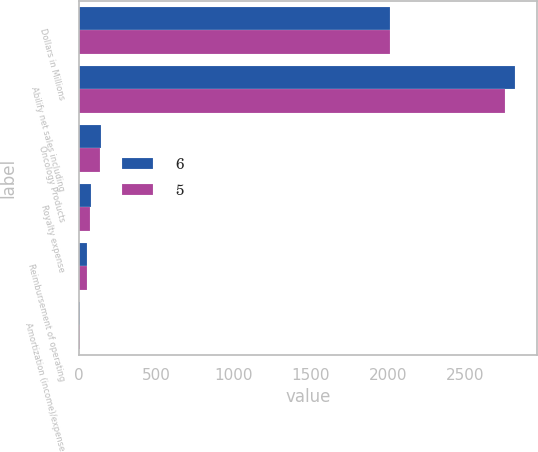Convert chart. <chart><loc_0><loc_0><loc_500><loc_500><stacked_bar_chart><ecel><fcel>Dollars in Millions<fcel>Abilify net sales including<fcel>Oncology Products<fcel>Royalty expense<fcel>Reimbursement of operating<fcel>Amortization (income)/expense<nl><fcel>6<fcel>2012<fcel>2827<fcel>138<fcel>78<fcel>49<fcel>5<nl><fcel>5<fcel>2011<fcel>2758<fcel>134<fcel>72<fcel>47<fcel>6<nl></chart> 